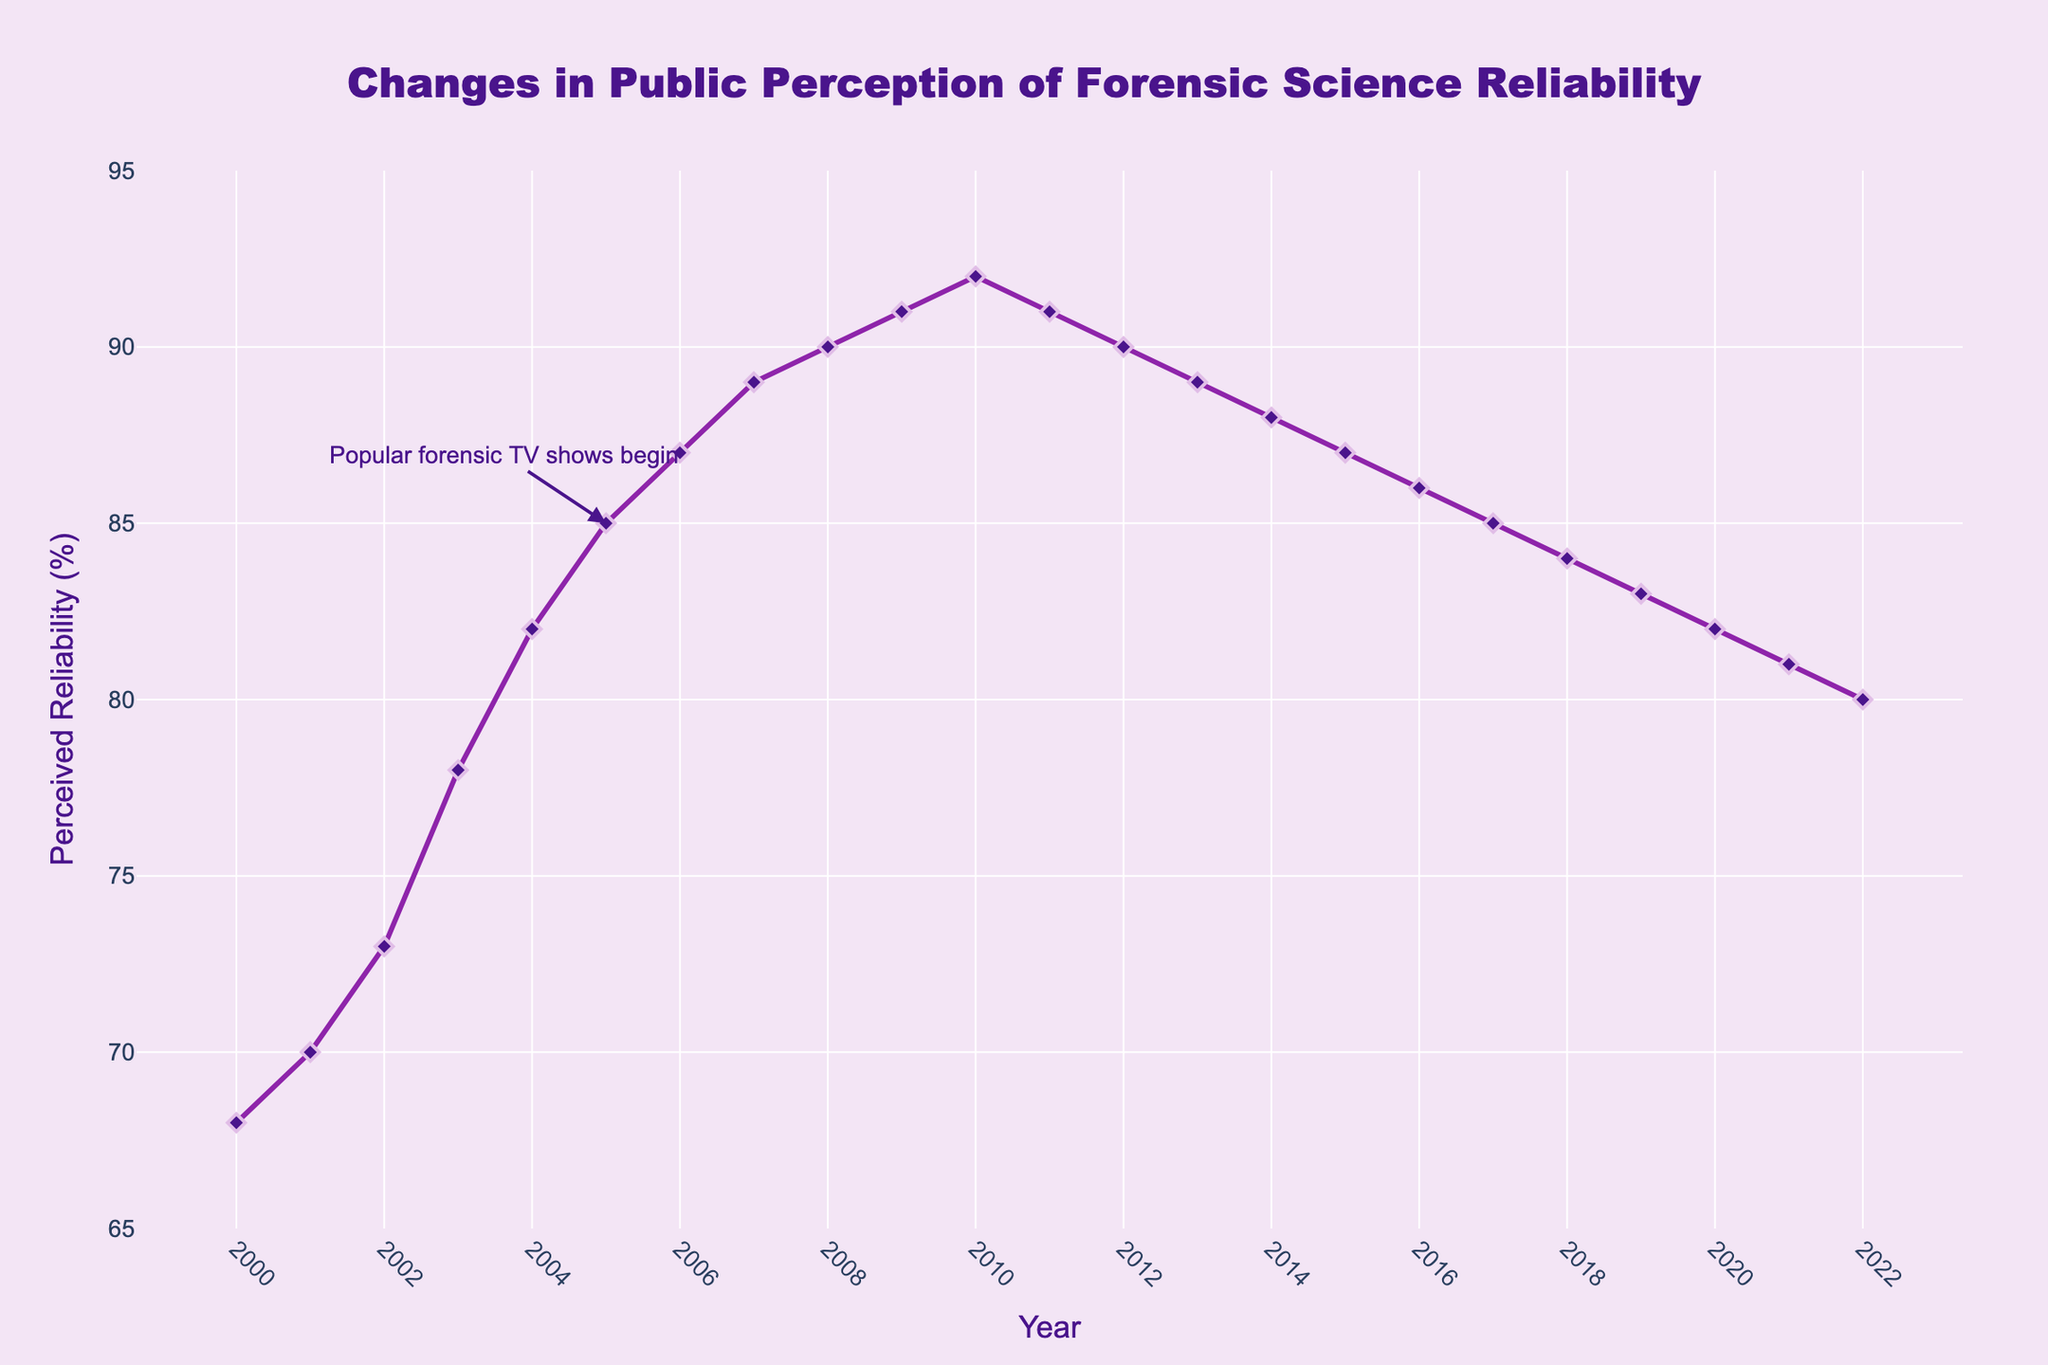What is the overall trend in perceived reliability from 2000 to 2022? The line chart shows that the perceived reliability of forensic science increased steadily from 2000 to 2009, reaching a peak in 2010. After 2010, there is a gradual decline in perceived reliability up to 2022.
Answer: An initial rise followed by a gradual decline By how many percentage points did the perceived reliability increase from 2000 to 2010? In 2000, the perceived reliability was 68%, and by 2010, it had increased to 92%. The increase is calculated as 92% - 68% = 24 percentage points.
Answer: 24 percentage points Which year marks the beginning of a decline in perceived reliability, and how does this compare to the peak year? The perceived reliability starts to decline after 2010; 2010 is the peak year with a perceived reliability of 92%. From 2011 onwards, the perceived reliability starts to drop.
Answer: 2011, compared to 2010 What was the perceived reliability when popular forensic TV shows began in 2005? The figure includes an annotation indicating that popular forensic TV shows began in 2005. The perceived reliability for that year is shown to be 85%.
Answer: 85% What is the average perceived reliability from 2000 to 2022? To find the average perceived reliability: Sum all the yearly perceived reliability percentages from 2000 to 2022 and divide by the number of years (23). The calculated sum is 1871, and the average is 1871 / 23 ≈ 81.35%.
Answer: 81.35% Between which two consecutive years did the greatest increase in perceived reliability occur? By observing the differences between consecutive years, the greatest increase occurs between 2002 and 2003 where the reliability rises from 73% to 78%, a 5 percentage points increase.
Answer: 2002 to 2003 What visual elements indicate the years when forensic TV shows started affecting perceived reliability? The line plot has an annotation with an arrow pointing to the year 2005, indicating this is when popular forensic TV shows began. This annotation helps visually distinguish this specific year.
Answer: Annotation in 2005 How much did the perceived reliability change from its lowest point to its highest point within the data range? The lowest point in the data is 68% in 2000. The highest point is 92% in 2010. The change is calculated as 92% - 68% = 24 percentage points.
Answer: 24 percentage points 